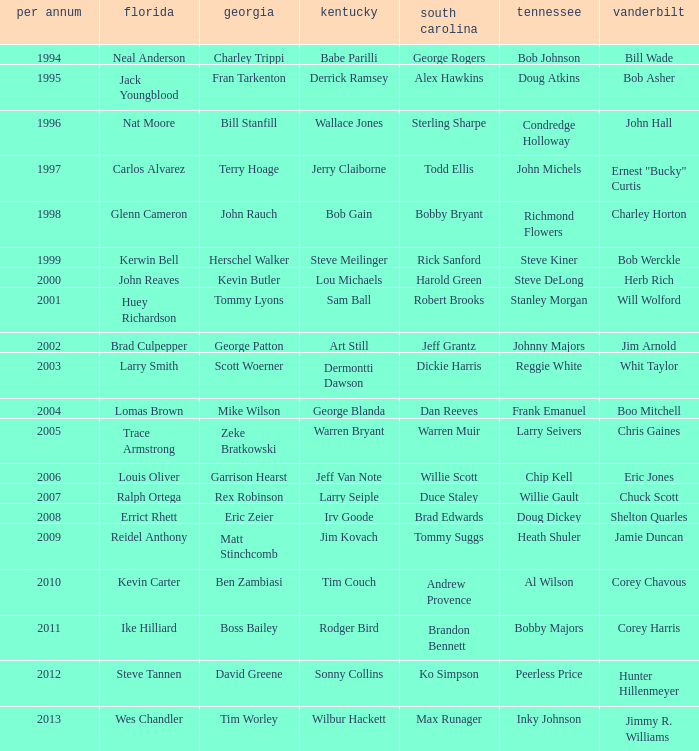What is the Tennessee that Georgia of kevin butler is in? Steve DeLong. 